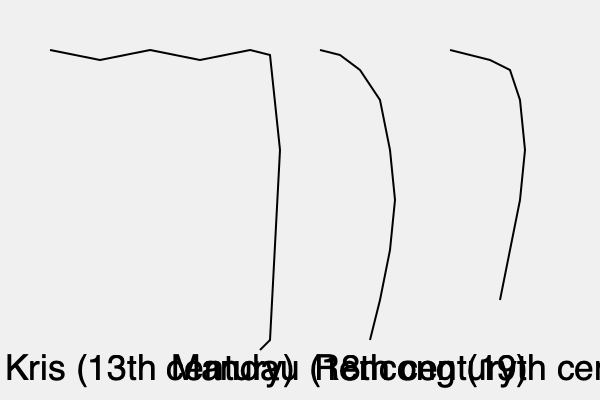Analyze the evolution of traditional Indonesian bladed weapons depicted in the image. Which weapon is likely to have originated first, and how does its design reflect the cultural and historical context of its time? To answer this question, we need to examine the three weapons shown in the image and consider their historical context:

1. Kris (13th century):
   - Wavy blade design
   - Oldest weapon shown (13th century)
   - Complex, ornate design suggesting a long period of development

2. Mandau (18th century):
   - Slightly curved blade
   - Simpler design compared to the Kris
   - Associated with the Dayak people of Borneo

3. Rencong (19th century):
   - Straight, dagger-like blade
   - Newest weapon shown
   - Associated with the Acehnese people

The Kris is likely to have originated first due to its earlier dating (13th century) and more complex design. Its wavy blade, known as "pamor," is a result of pattern-welding techniques that developed over centuries. This complexity suggests a long period of cultural and technological evolution.

The Kris's design reflects:
1. Advanced metalworking techniques of medieval Indonesia
2. Spiritual and mystical beliefs (Kris were often considered to have magical properties)
3. Social status (more elaborate Kris were owned by nobility)
4. Influence of Hindu-Buddhist culture in early Indonesian kingdoms

The Kris's early origin and intricate design make it the most likely candidate for the first weapon to have originated among those shown.
Answer: Kris (13th century) 